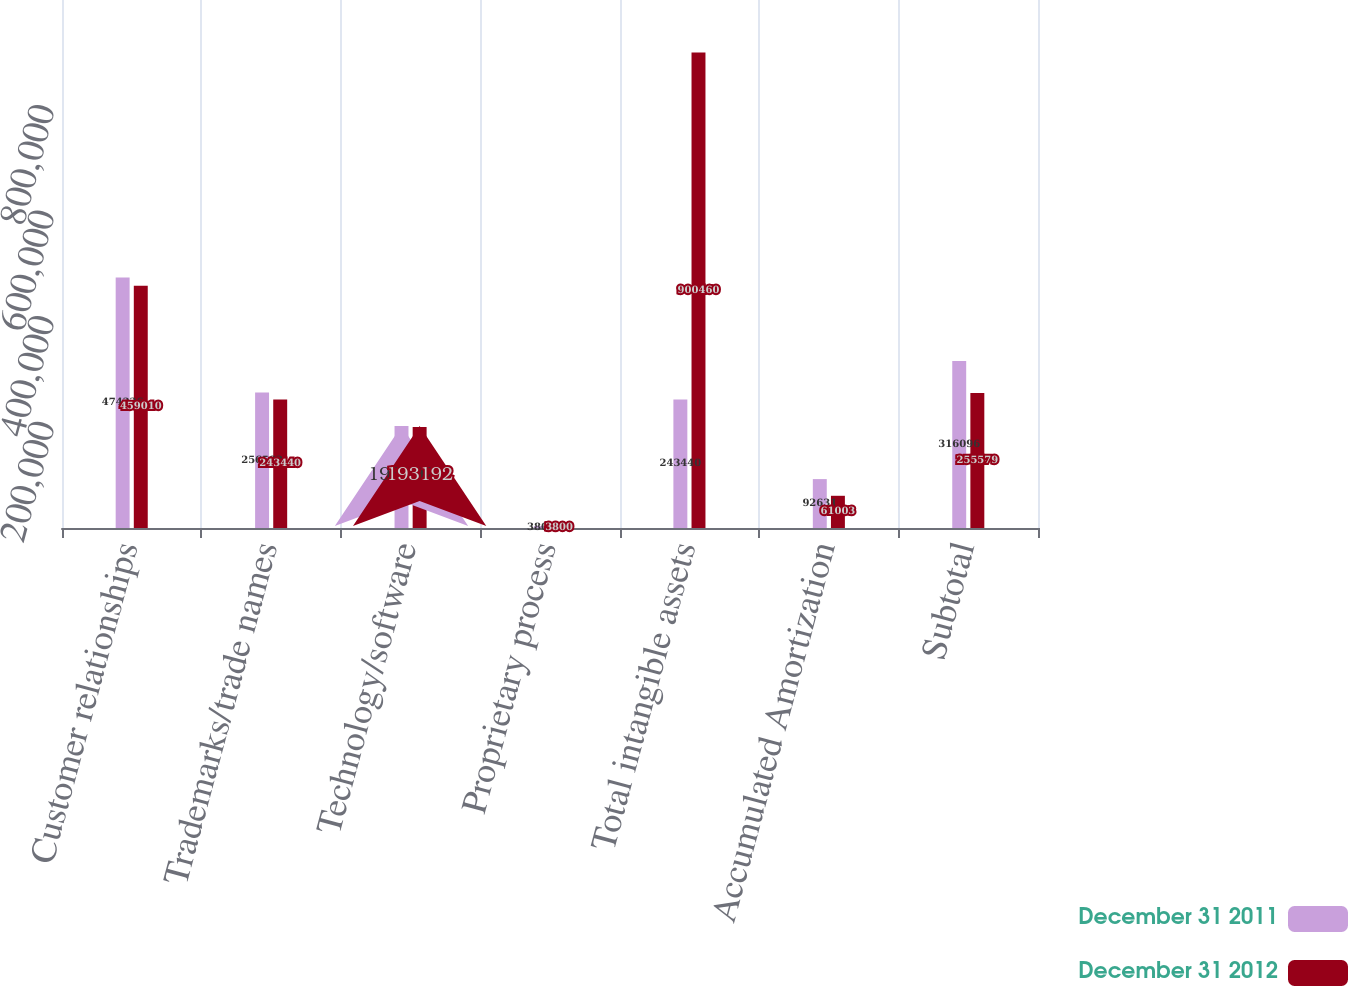<chart> <loc_0><loc_0><loc_500><loc_500><stacked_bar_chart><ecel><fcel>Customer relationships<fcel>Trademarks/trade names<fcel>Technology/software<fcel>Proprietary process<fcel>Total intangible assets<fcel>Accumulated Amortization<fcel>Subtotal<nl><fcel>December 31 2011<fcel>474236<fcel>256582<fcel>193192<fcel>3800<fcel>243440<fcel>92631<fcel>316096<nl><fcel>December 31 2012<fcel>459010<fcel>243440<fcel>191430<fcel>3800<fcel>900460<fcel>61003<fcel>255579<nl></chart> 